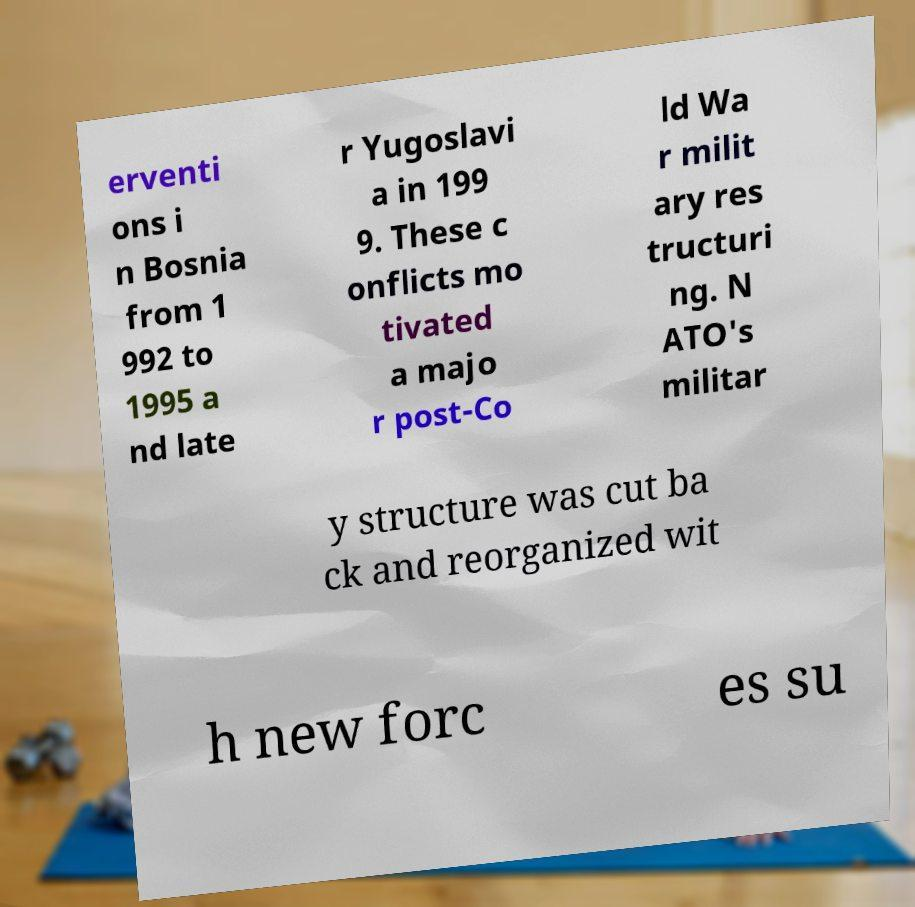There's text embedded in this image that I need extracted. Can you transcribe it verbatim? erventi ons i n Bosnia from 1 992 to 1995 a nd late r Yugoslavi a in 199 9. These c onflicts mo tivated a majo r post-Co ld Wa r milit ary res tructuri ng. N ATO's militar y structure was cut ba ck and reorganized wit h new forc es su 